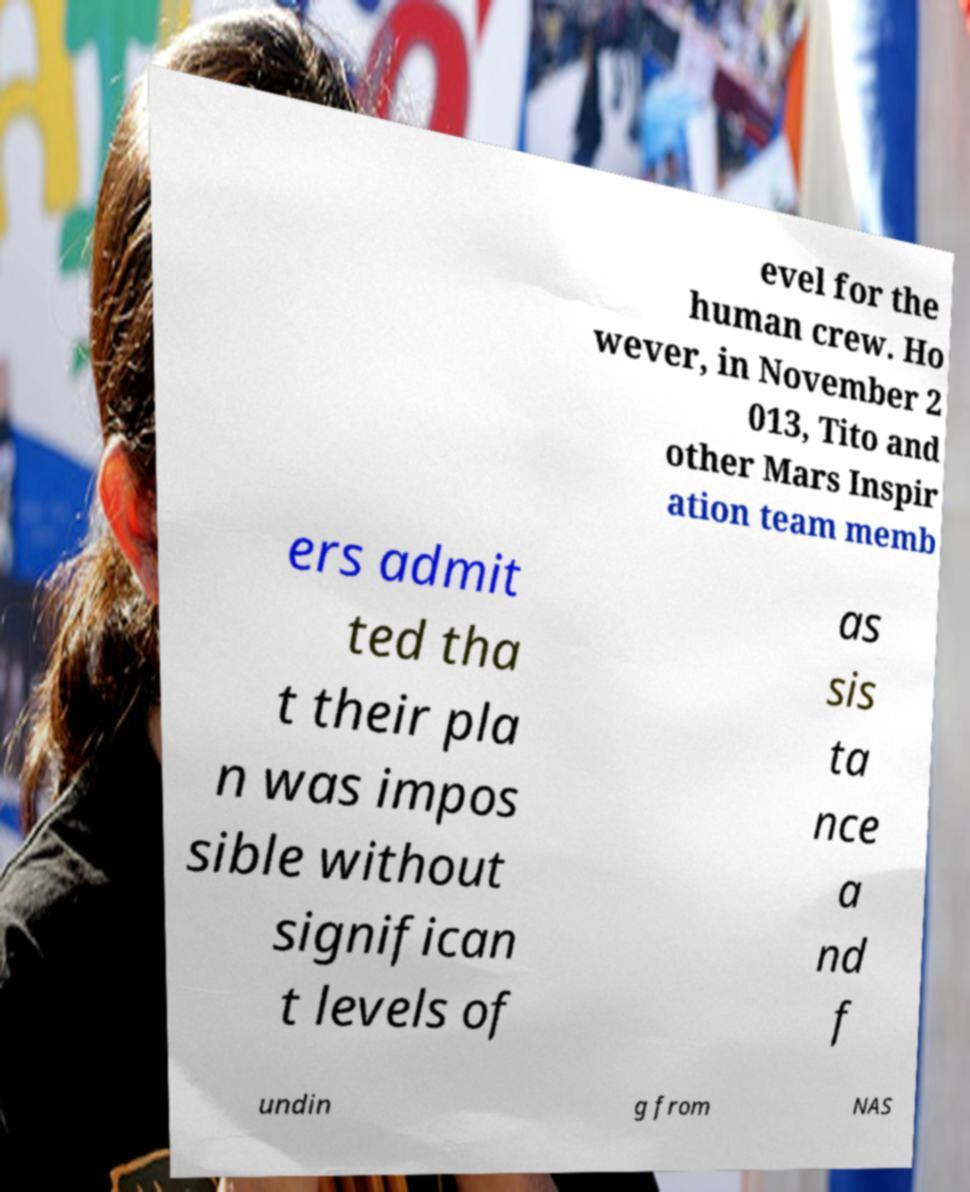Can you read and provide the text displayed in the image?This photo seems to have some interesting text. Can you extract and type it out for me? evel for the human crew. Ho wever, in November 2 013, Tito and other Mars Inspir ation team memb ers admit ted tha t their pla n was impos sible without significan t levels of as sis ta nce a nd f undin g from NAS 